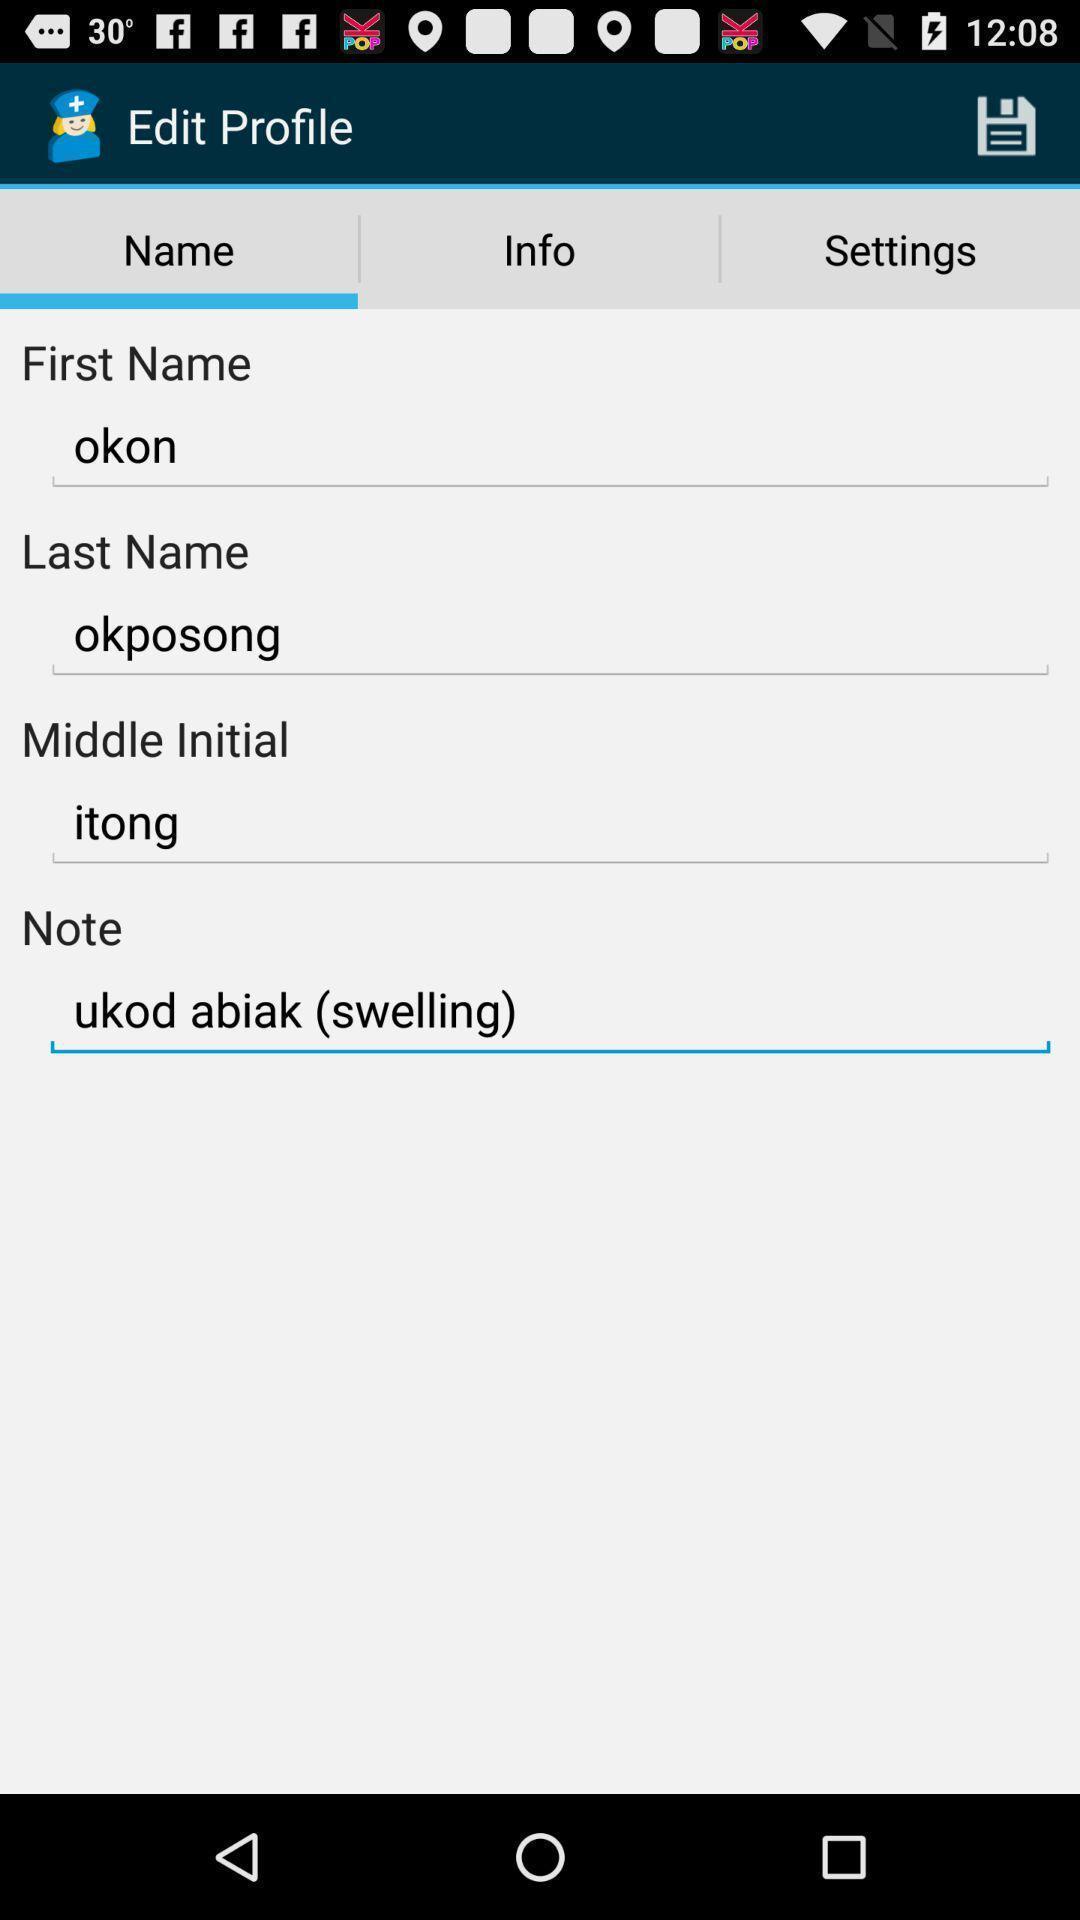Tell me what you see in this picture. Screen displaying to edit profile. 